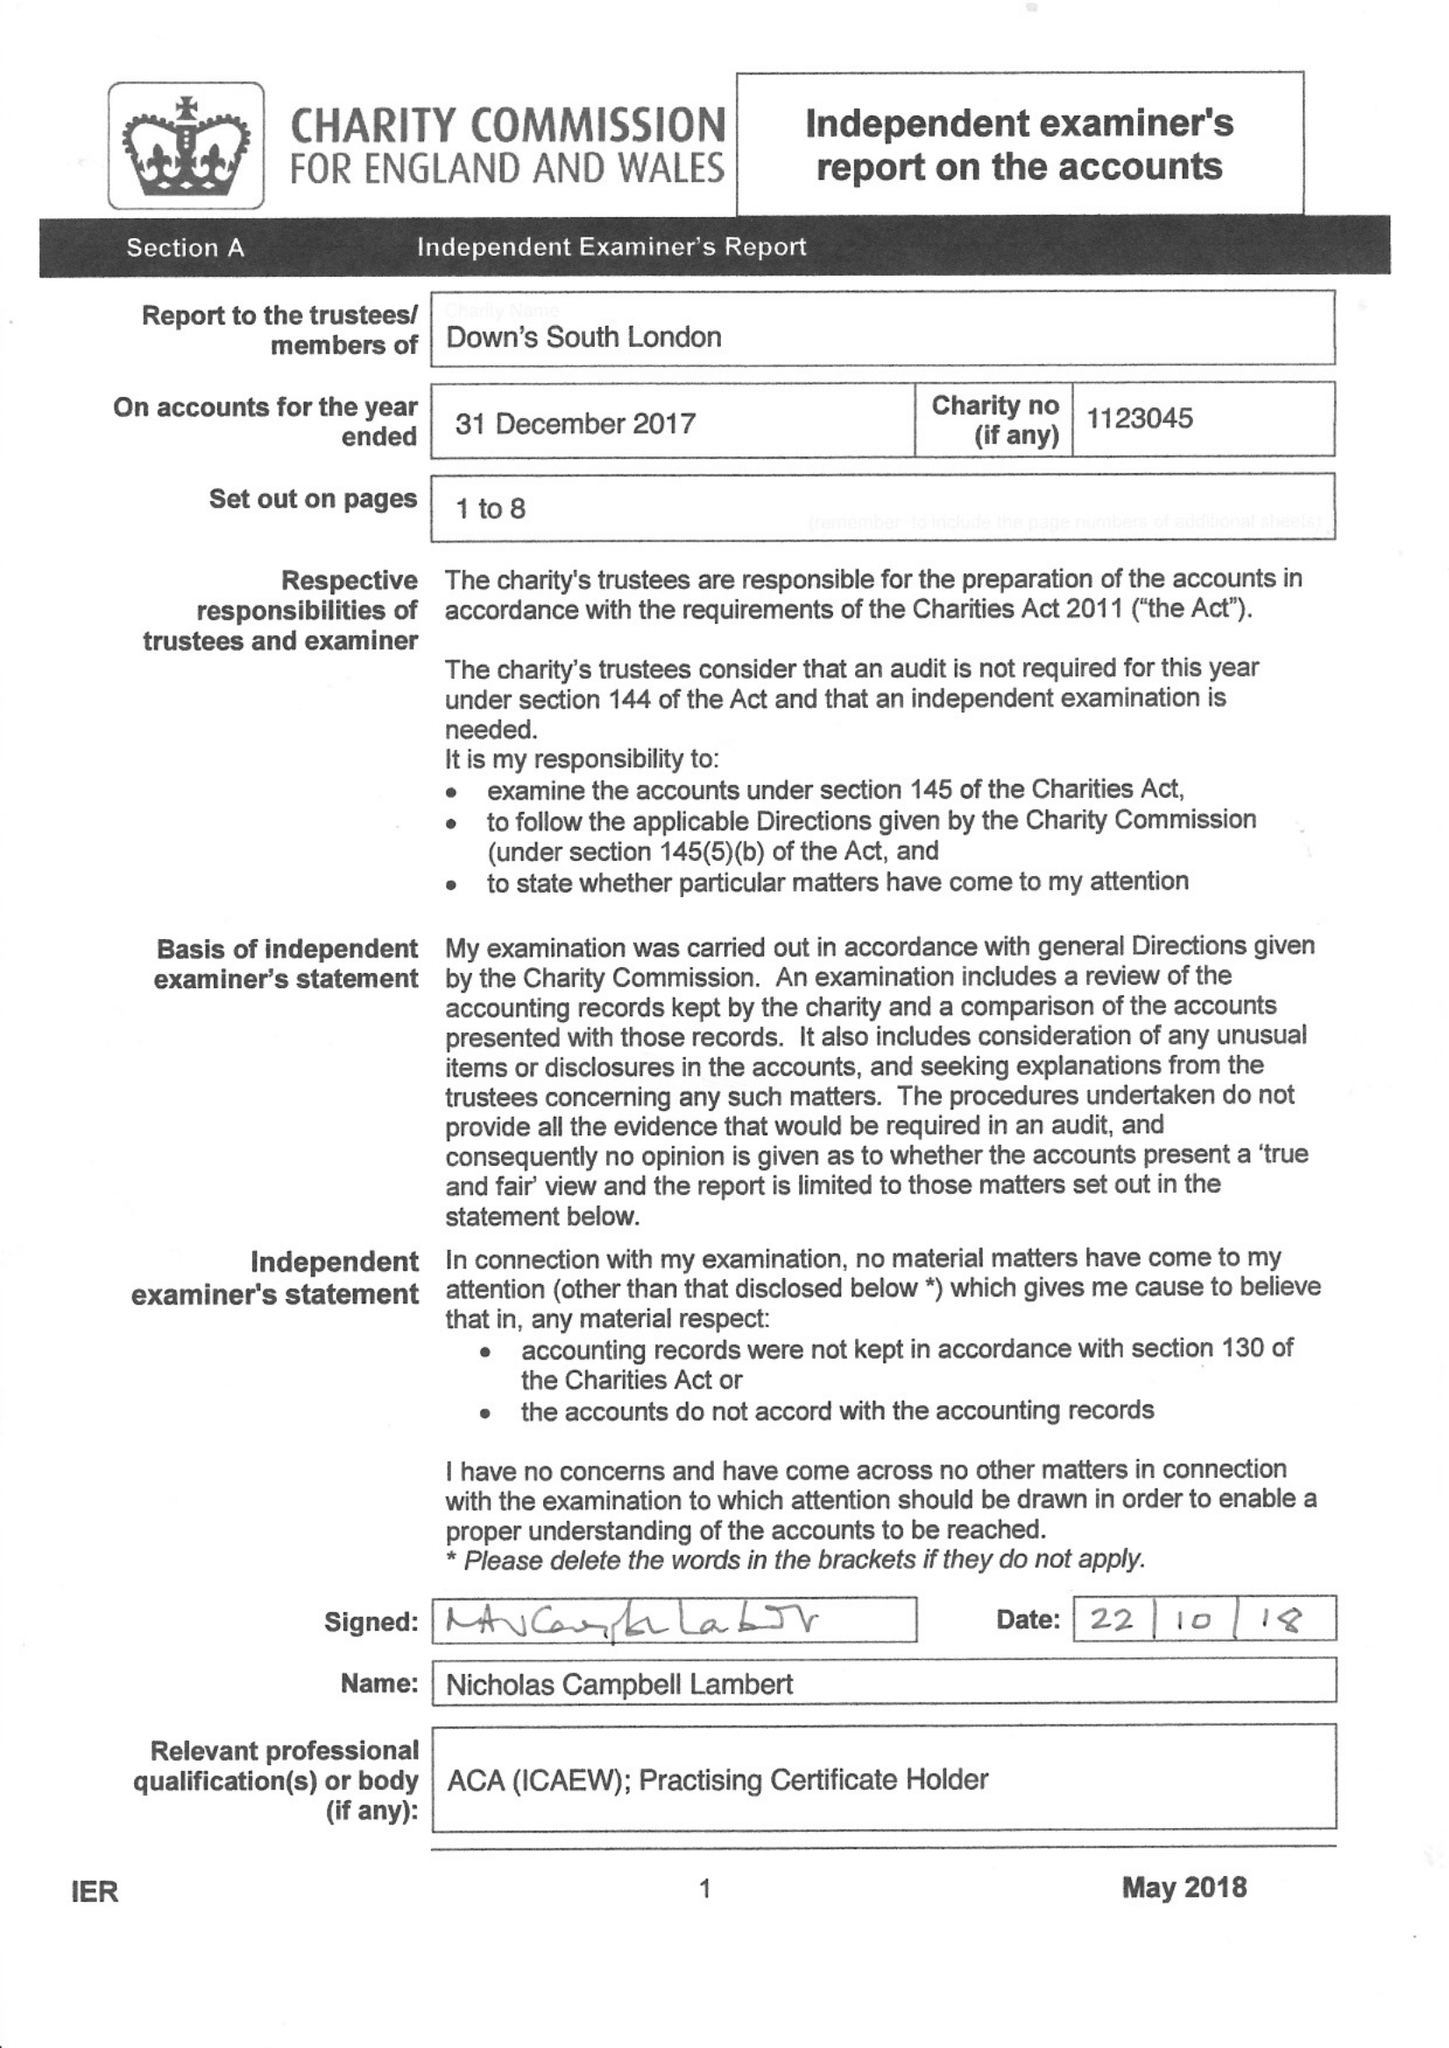What is the value for the address__postcode?
Answer the question using a single word or phrase. SE15 5AW 